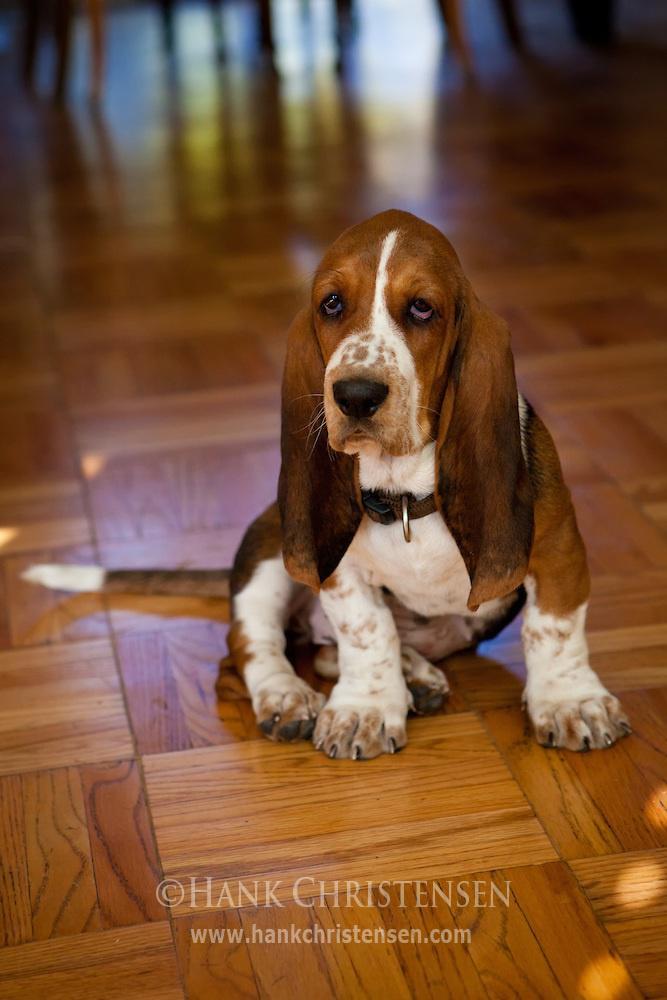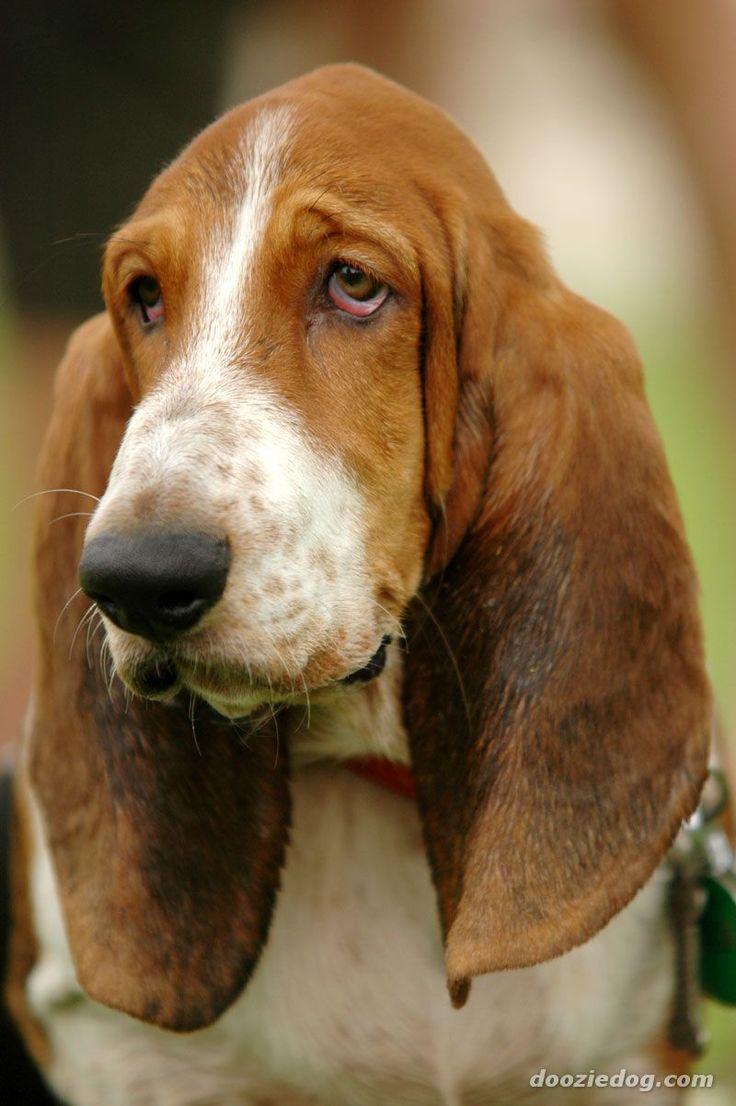The first image is the image on the left, the second image is the image on the right. For the images shown, is this caption "One image features a basset pup on a wood plank deck outdoors." true? Answer yes or no. No. The first image is the image on the left, the second image is the image on the right. Analyze the images presented: Is the assertion "the dog's tail is visible in one of the images" valid? Answer yes or no. Yes. 